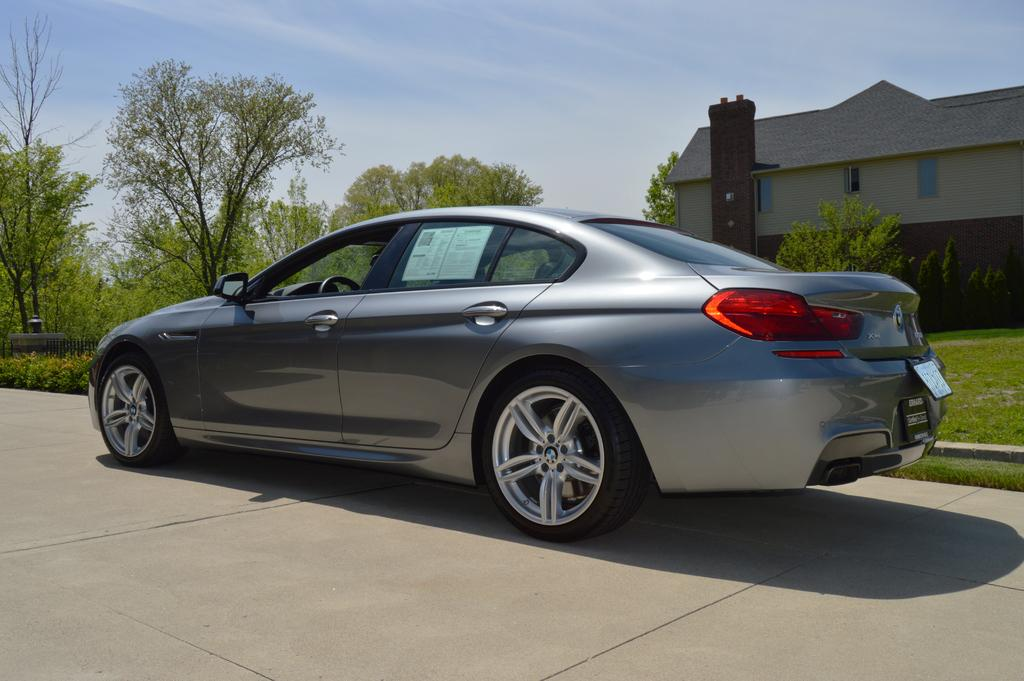What is the main subject of the image? The main subject of the image is a car on the road. What can be seen on the surface behind the car? There is grass on the surface behind the car. What is visible in the background of the image? Trees, a building, and the sky are visible in the background of the image. How many birds can be seen blowing bubbles in the image? There are no birds or bubbles present in the image. 